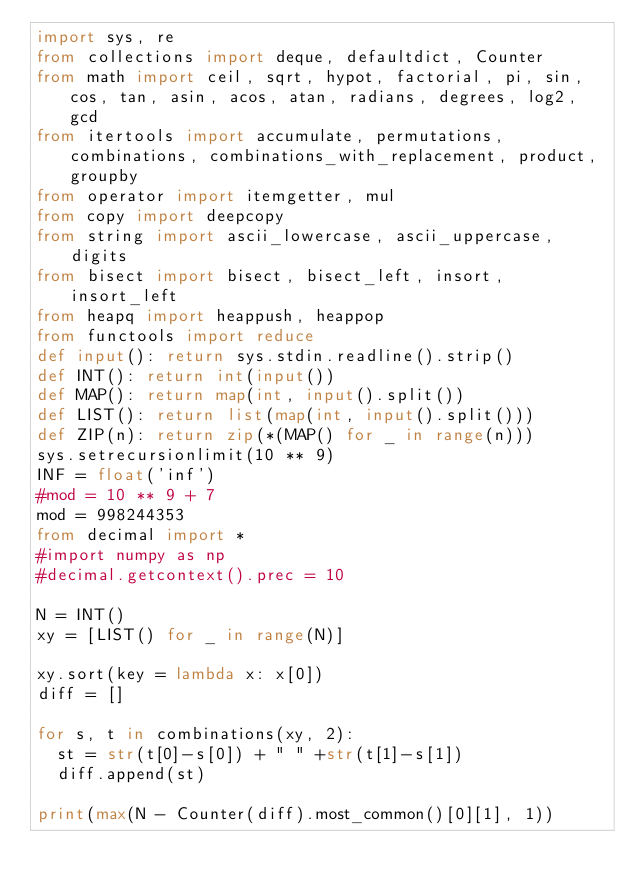<code> <loc_0><loc_0><loc_500><loc_500><_Python_>import sys, re
from collections import deque, defaultdict, Counter
from math import ceil, sqrt, hypot, factorial, pi, sin, cos, tan, asin, acos, atan, radians, degrees, log2, gcd
from itertools import accumulate, permutations, combinations, combinations_with_replacement, product, groupby
from operator import itemgetter, mul
from copy import deepcopy
from string import ascii_lowercase, ascii_uppercase, digits
from bisect import bisect, bisect_left, insort, insort_left
from heapq import heappush, heappop
from functools import reduce
def input(): return sys.stdin.readline().strip()
def INT(): return int(input())
def MAP(): return map(int, input().split())
def LIST(): return list(map(int, input().split()))
def ZIP(n): return zip(*(MAP() for _ in range(n)))
sys.setrecursionlimit(10 ** 9)
INF = float('inf')
#mod = 10 ** 9 + 7 
mod = 998244353
from decimal import *
#import numpy as np
#decimal.getcontext().prec = 10

N = INT()
xy = [LIST() for _ in range(N)]

xy.sort(key = lambda x: x[0])
diff = []

for s, t in combinations(xy, 2):
	st = str(t[0]-s[0]) + " " +str(t[1]-s[1])
	diff.append(st)

print(max(N - Counter(diff).most_common()[0][1], 1))
</code> 